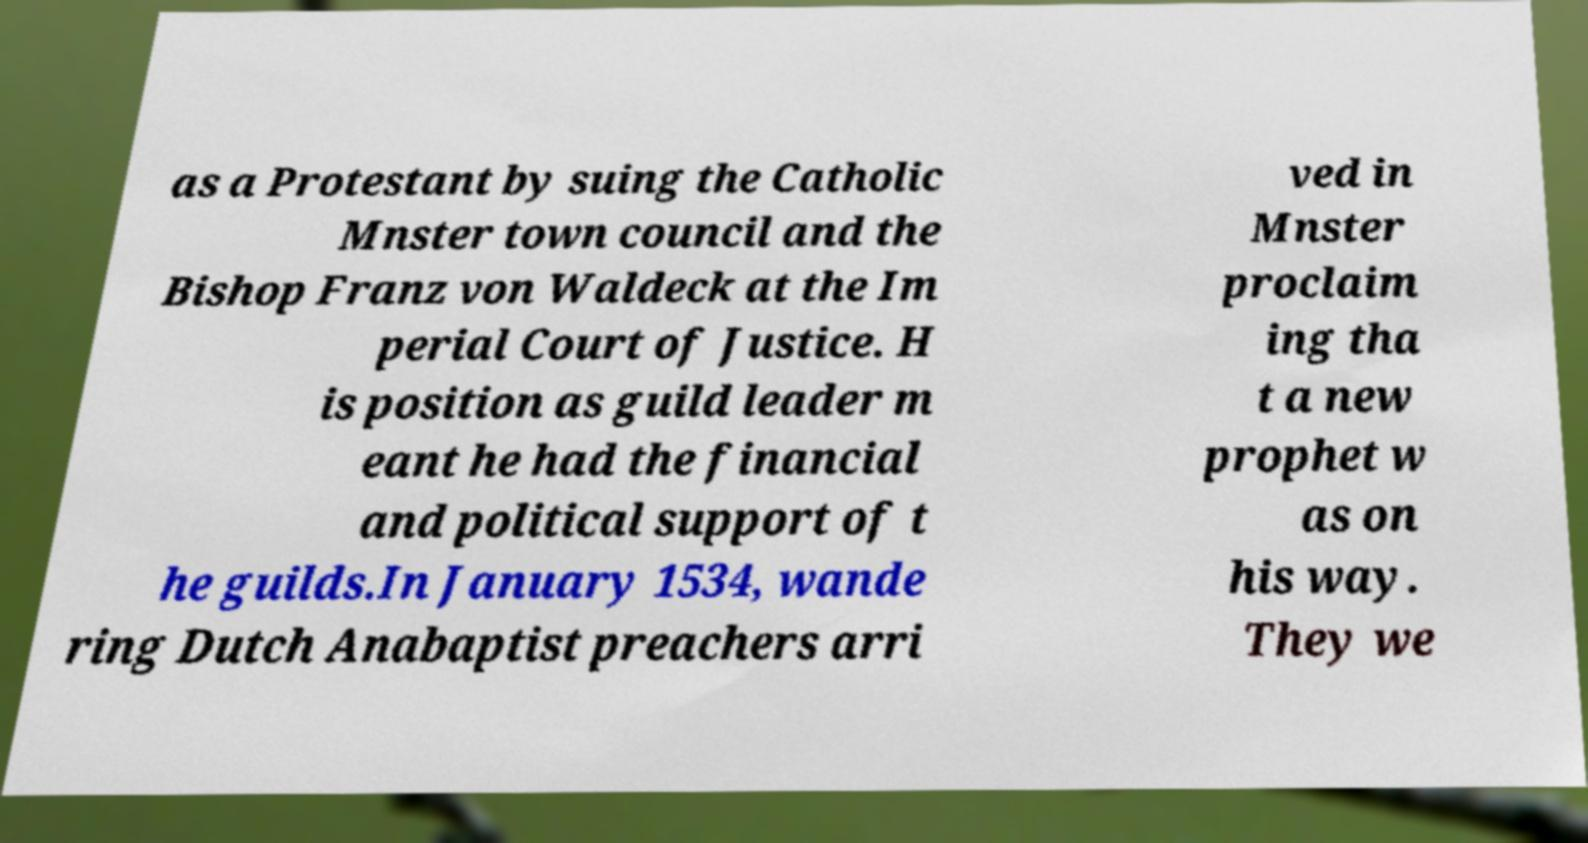What messages or text are displayed in this image? I need them in a readable, typed format. as a Protestant by suing the Catholic Mnster town council and the Bishop Franz von Waldeck at the Im perial Court of Justice. H is position as guild leader m eant he had the financial and political support of t he guilds.In January 1534, wande ring Dutch Anabaptist preachers arri ved in Mnster proclaim ing tha t a new prophet w as on his way. They we 